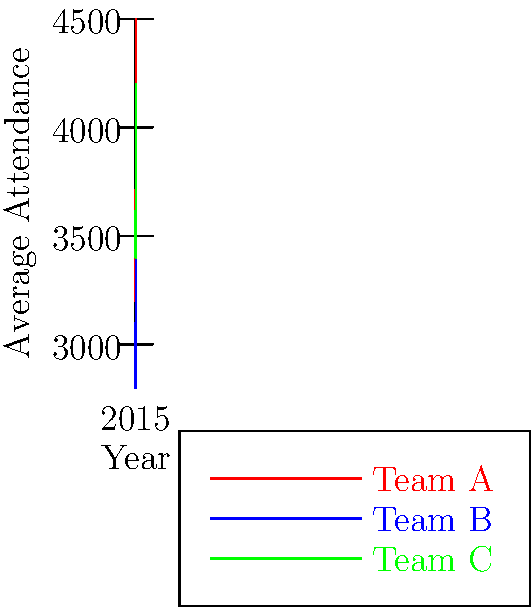Based on the line graph showing attendance trends for three Independent League Baseball teams from 2015 to 2019, which team experienced the most consistent year-over-year growth in average attendance? Additionally, calculate the percentage increase in attendance for this team from 2015 to 2019. To answer this question, we need to analyze the trends for each team:

1. Team A (red line):
   - Shows consistent upward trend
   - No decreases in attendance
   - Steady increase each year

2. Team B (blue line):
   - Overall upward trend
   - Slight decrease from 2016 to 2017
   - Less consistent growth

3. Team C (green line):
   - Overall upward trend
   - Decrease from 2015 to 2016
   - Less consistent growth

Team A shows the most consistent year-over-year growth.

To calculate the percentage increase for Team A from 2015 to 2019:

1. 2015 attendance: 3200
2. 2019 attendance: 4500
3. Increase: 4500 - 3200 = 1300
4. Percentage increase: $\frac{1300}{3200} \times 100 = 40.625\%$

Therefore, Team A experienced a 40.625% increase in attendance from 2015 to 2019.
Answer: Team A; 40.625% increase 